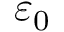<formula> <loc_0><loc_0><loc_500><loc_500>\varepsilon _ { 0 }</formula> 